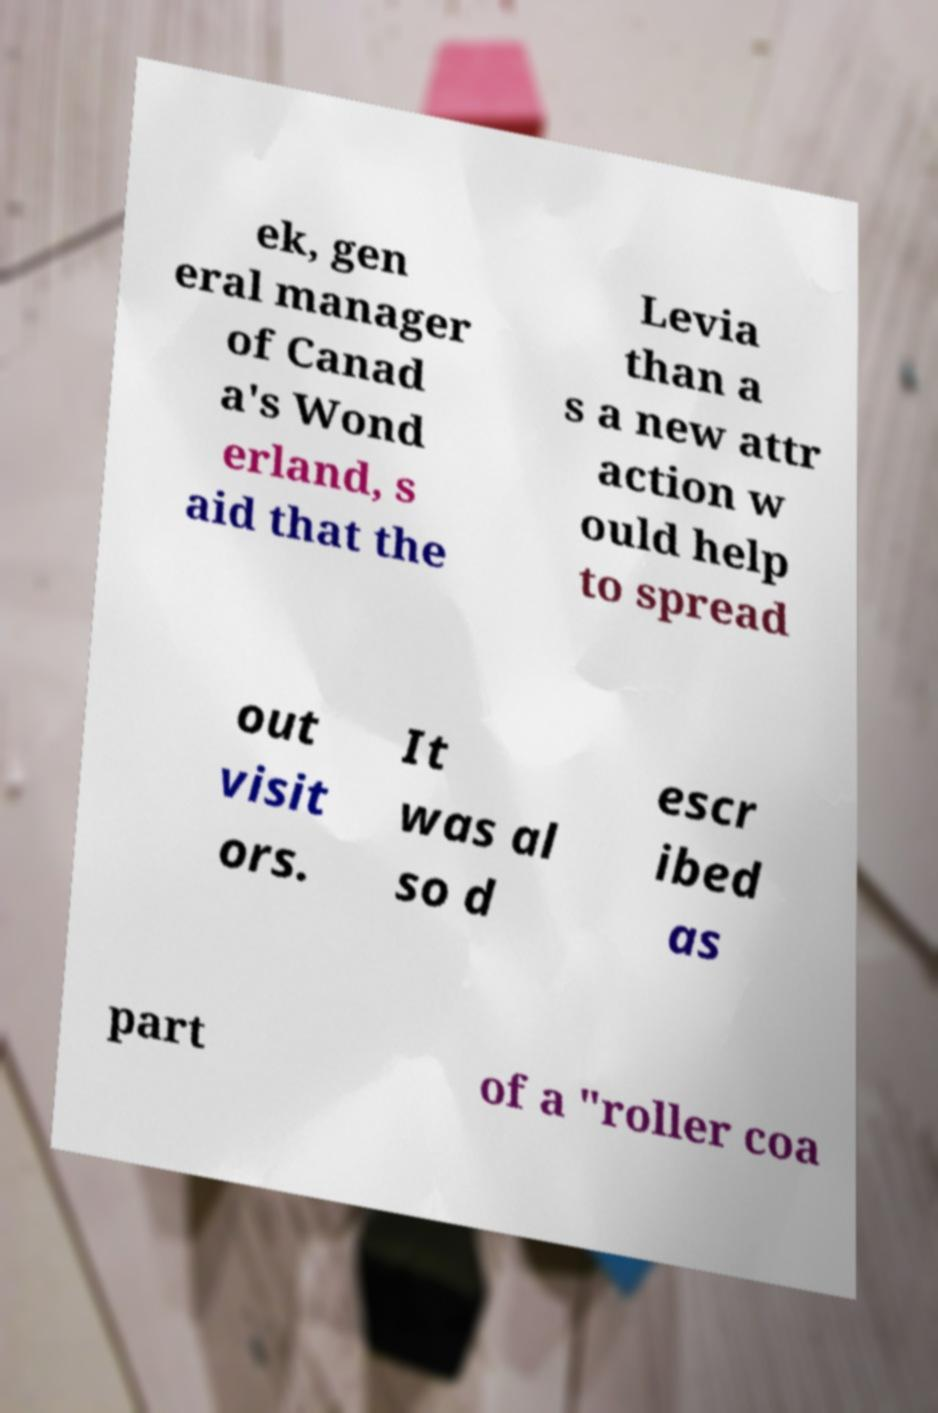Can you read and provide the text displayed in the image?This photo seems to have some interesting text. Can you extract and type it out for me? ek, gen eral manager of Canad a's Wond erland, s aid that the Levia than a s a new attr action w ould help to spread out visit ors. It was al so d escr ibed as part of a "roller coa 